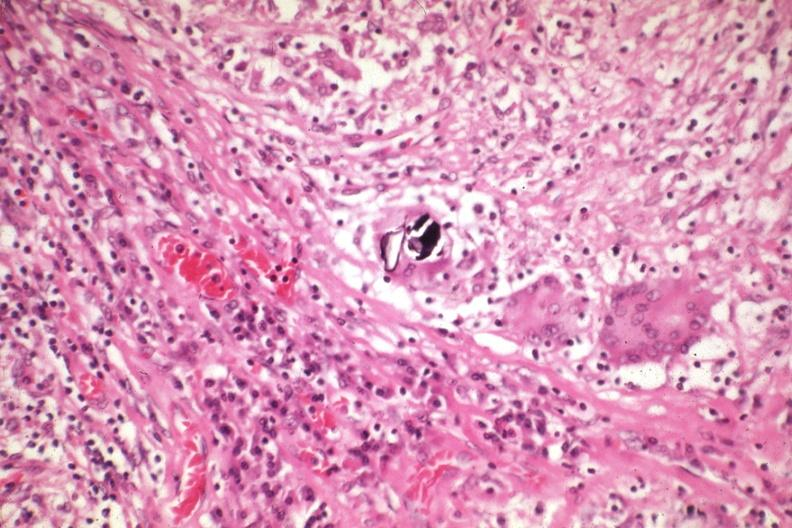s spina bifida present?
Answer the question using a single word or phrase. No 